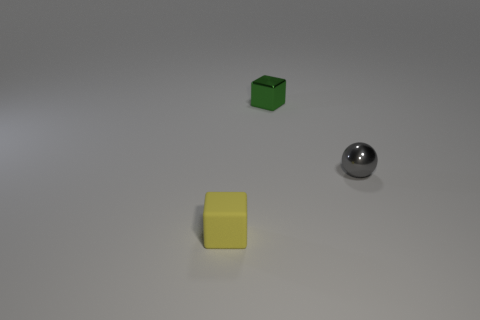Is there anything else that has the same material as the tiny yellow cube?
Your answer should be very brief. No. Are there more things that are on the right side of the rubber block than small gray things that are to the left of the gray ball?
Your response must be concise. Yes. What number of tiny balls are right of the tiny shiny object behind the small sphere?
Provide a succinct answer. 1. There is a tiny cube on the left side of the block to the right of the yellow rubber object; what color is it?
Offer a terse response. Yellow. What number of rubber things are either yellow things or green blocks?
Your response must be concise. 1. Are there any tiny yellow blocks that have the same material as the tiny yellow object?
Give a very brief answer. No. What number of tiny things are both in front of the small green metallic block and on the left side of the tiny gray metal thing?
Give a very brief answer. 1. Are there fewer rubber blocks right of the green cube than tiny things that are on the right side of the yellow thing?
Make the answer very short. Yes. Does the yellow matte object have the same shape as the small gray object?
Provide a succinct answer. No. What number of objects are metallic objects to the left of the small ball or tiny objects to the left of the tiny gray ball?
Your answer should be compact. 2. 